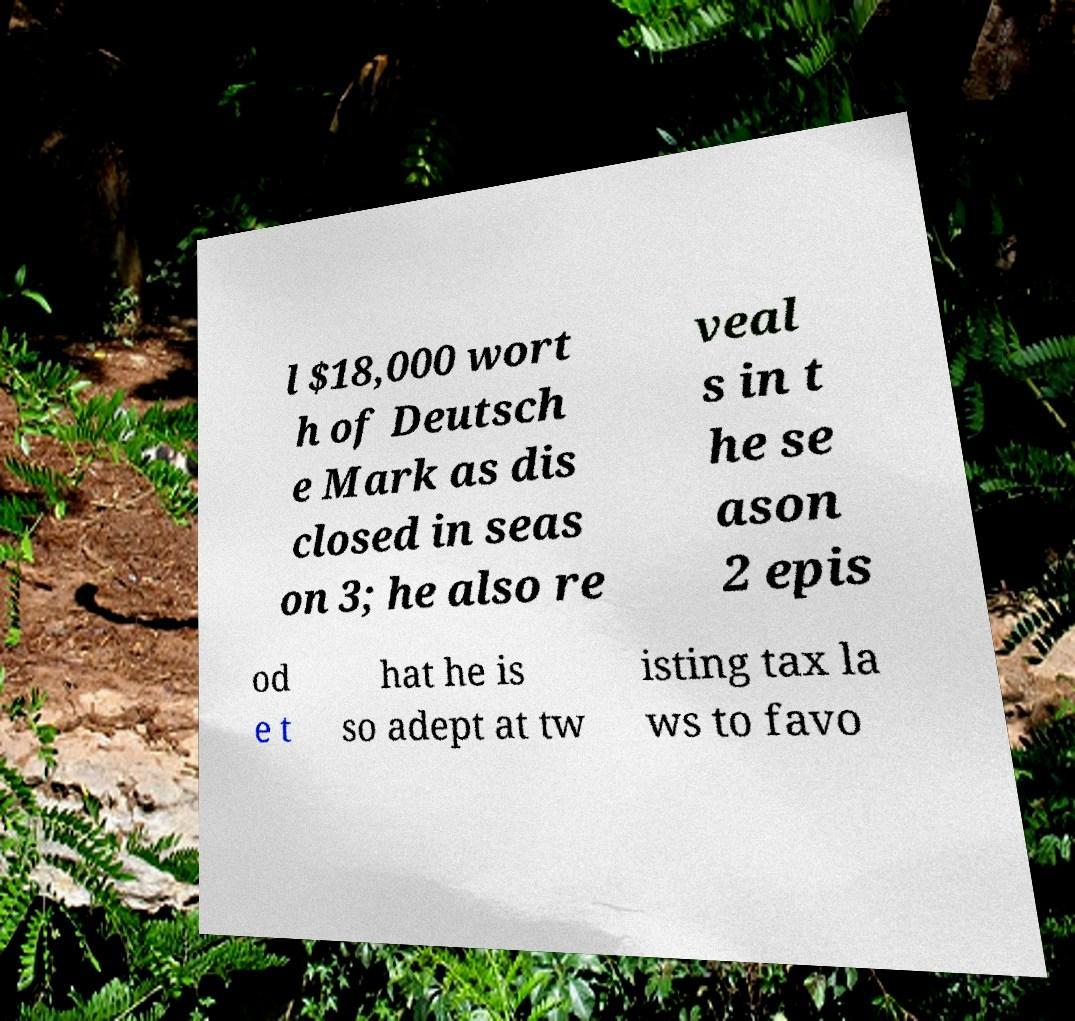Please read and relay the text visible in this image. What does it say? l $18,000 wort h of Deutsch e Mark as dis closed in seas on 3; he also re veal s in t he se ason 2 epis od e t hat he is so adept at tw isting tax la ws to favo 